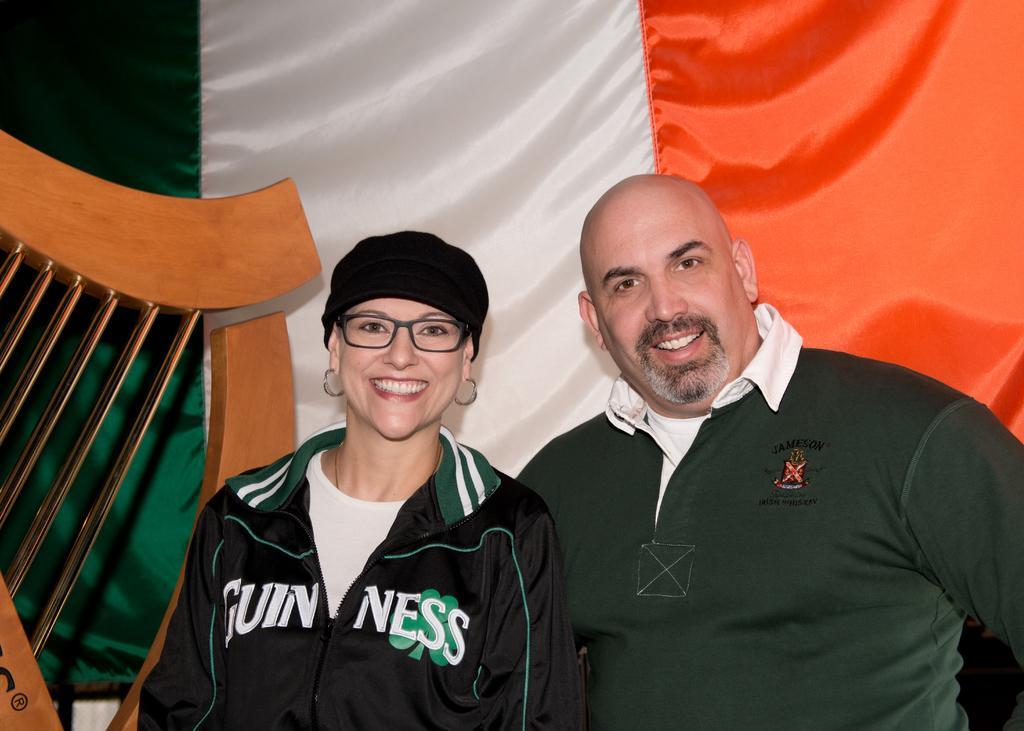Please provide a concise description of this image. In this image we can see a man and a woman. Behind them, we can see a curtain which is in multicolor. On the left side, we can see a wooden object. 